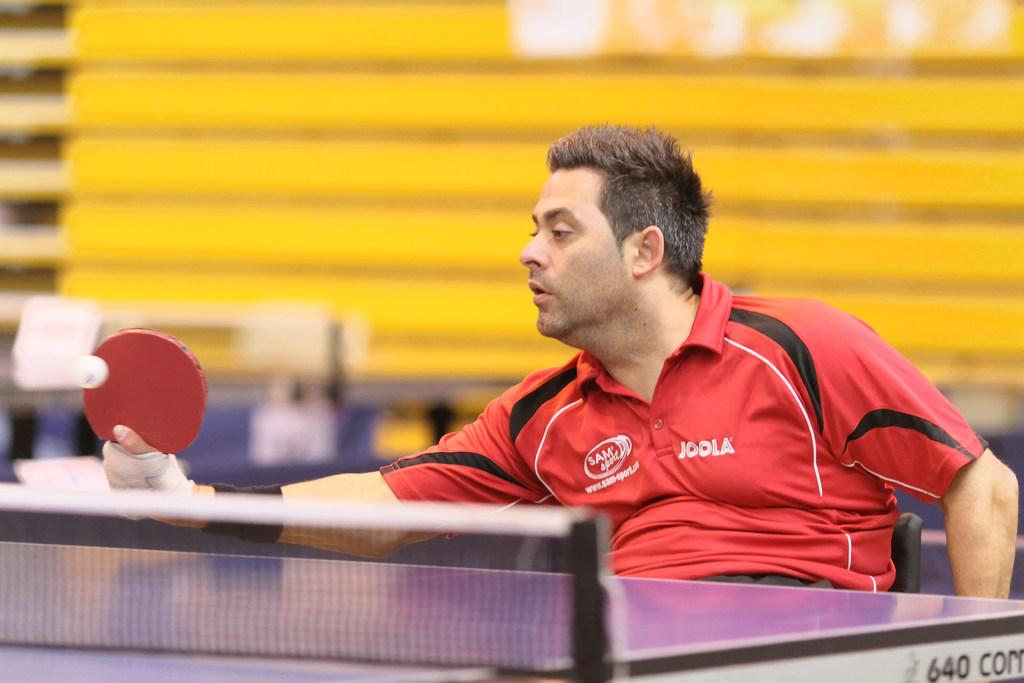What is the person in the image doing? The person is sitting on a chair in the image. What object is the person holding in his hand? The person is holding a bat in his hand. What can be seen in the background of the image? Walls, a ball, and a sports net are visible in the background of the image. How does the person's stomach feel while sitting on the chair in the image? There is no information provided about the person's stomach or how they feel in the image, so it cannot be determined. 